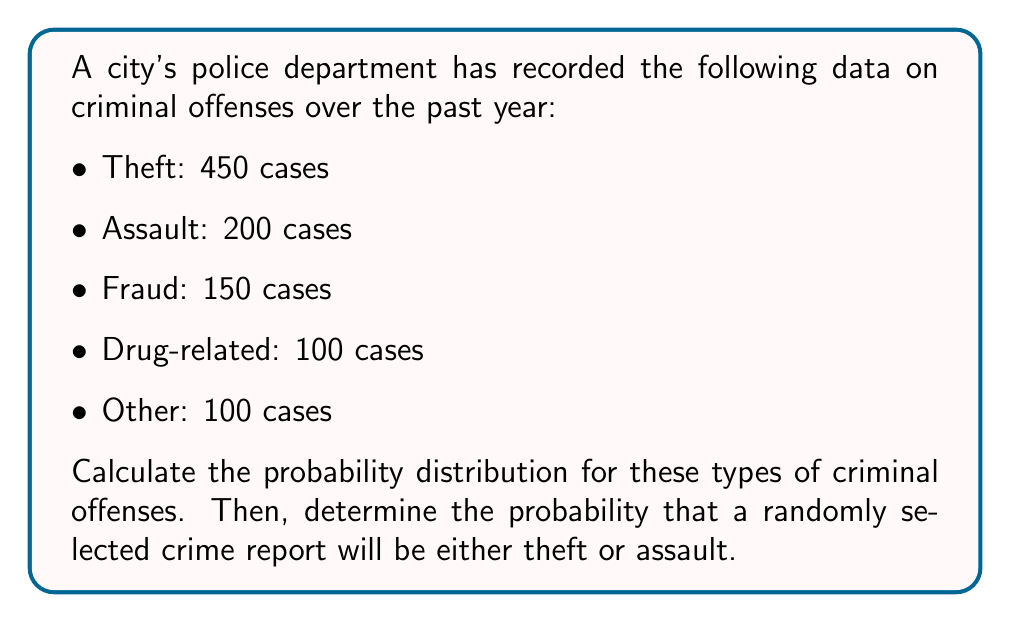Give your solution to this math problem. To calculate the probability distribution and solve this problem, we'll follow these steps:

1. Calculate the total number of criminal offenses:
   $$ \text{Total} = 450 + 200 + 150 + 100 + 100 = 1000 $$

2. Calculate the probability for each type of offense:
   $$ P(\text{Theft}) = \frac{450}{1000} = 0.45 $$
   $$ P(\text{Assault}) = \frac{200}{1000} = 0.20 $$
   $$ P(\text{Fraud}) = \frac{150}{1000} = 0.15 $$
   $$ P(\text{Drug-related}) = \frac{100}{1000} = 0.10 $$
   $$ P(\text{Other}) = \frac{100}{1000} = 0.10 $$

3. Verify that the probabilities sum to 1:
   $$ 0.45 + 0.20 + 0.15 + 0.10 + 0.10 = 1.00 $$

4. To find the probability that a randomly selected crime report will be either theft or assault, we add their individual probabilities:
   $$ P(\text{Theft or Assault}) = P(\text{Theft}) + P(\text{Assault}) = 0.45 + 0.20 = 0.65 $$

This means there's a 65% chance that a randomly selected crime report will be either theft or assault.
Answer: The probability distribution for the criminal offenses is:
Theft: 0.45
Assault: 0.20
Fraud: 0.15
Drug-related: 0.10
Other: 0.10

The probability that a randomly selected crime report will be either theft or assault is 0.65 or 65%. 